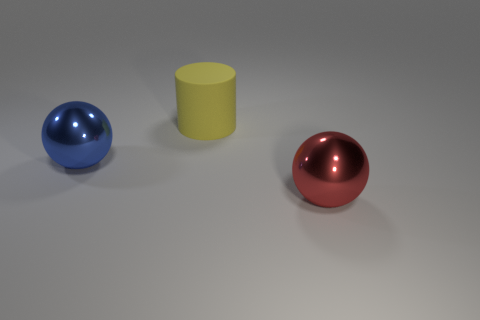Subtract all cylinders. How many objects are left? 2 Subtract 0 purple blocks. How many objects are left? 3 Subtract all green cylinders. Subtract all red blocks. How many cylinders are left? 1 Subtract all cyan cylinders. How many green balls are left? 0 Subtract all tiny brown things. Subtract all big blue balls. How many objects are left? 2 Add 2 large metallic spheres. How many large metallic spheres are left? 4 Add 1 metal balls. How many metal balls exist? 3 Add 3 big red spheres. How many objects exist? 6 